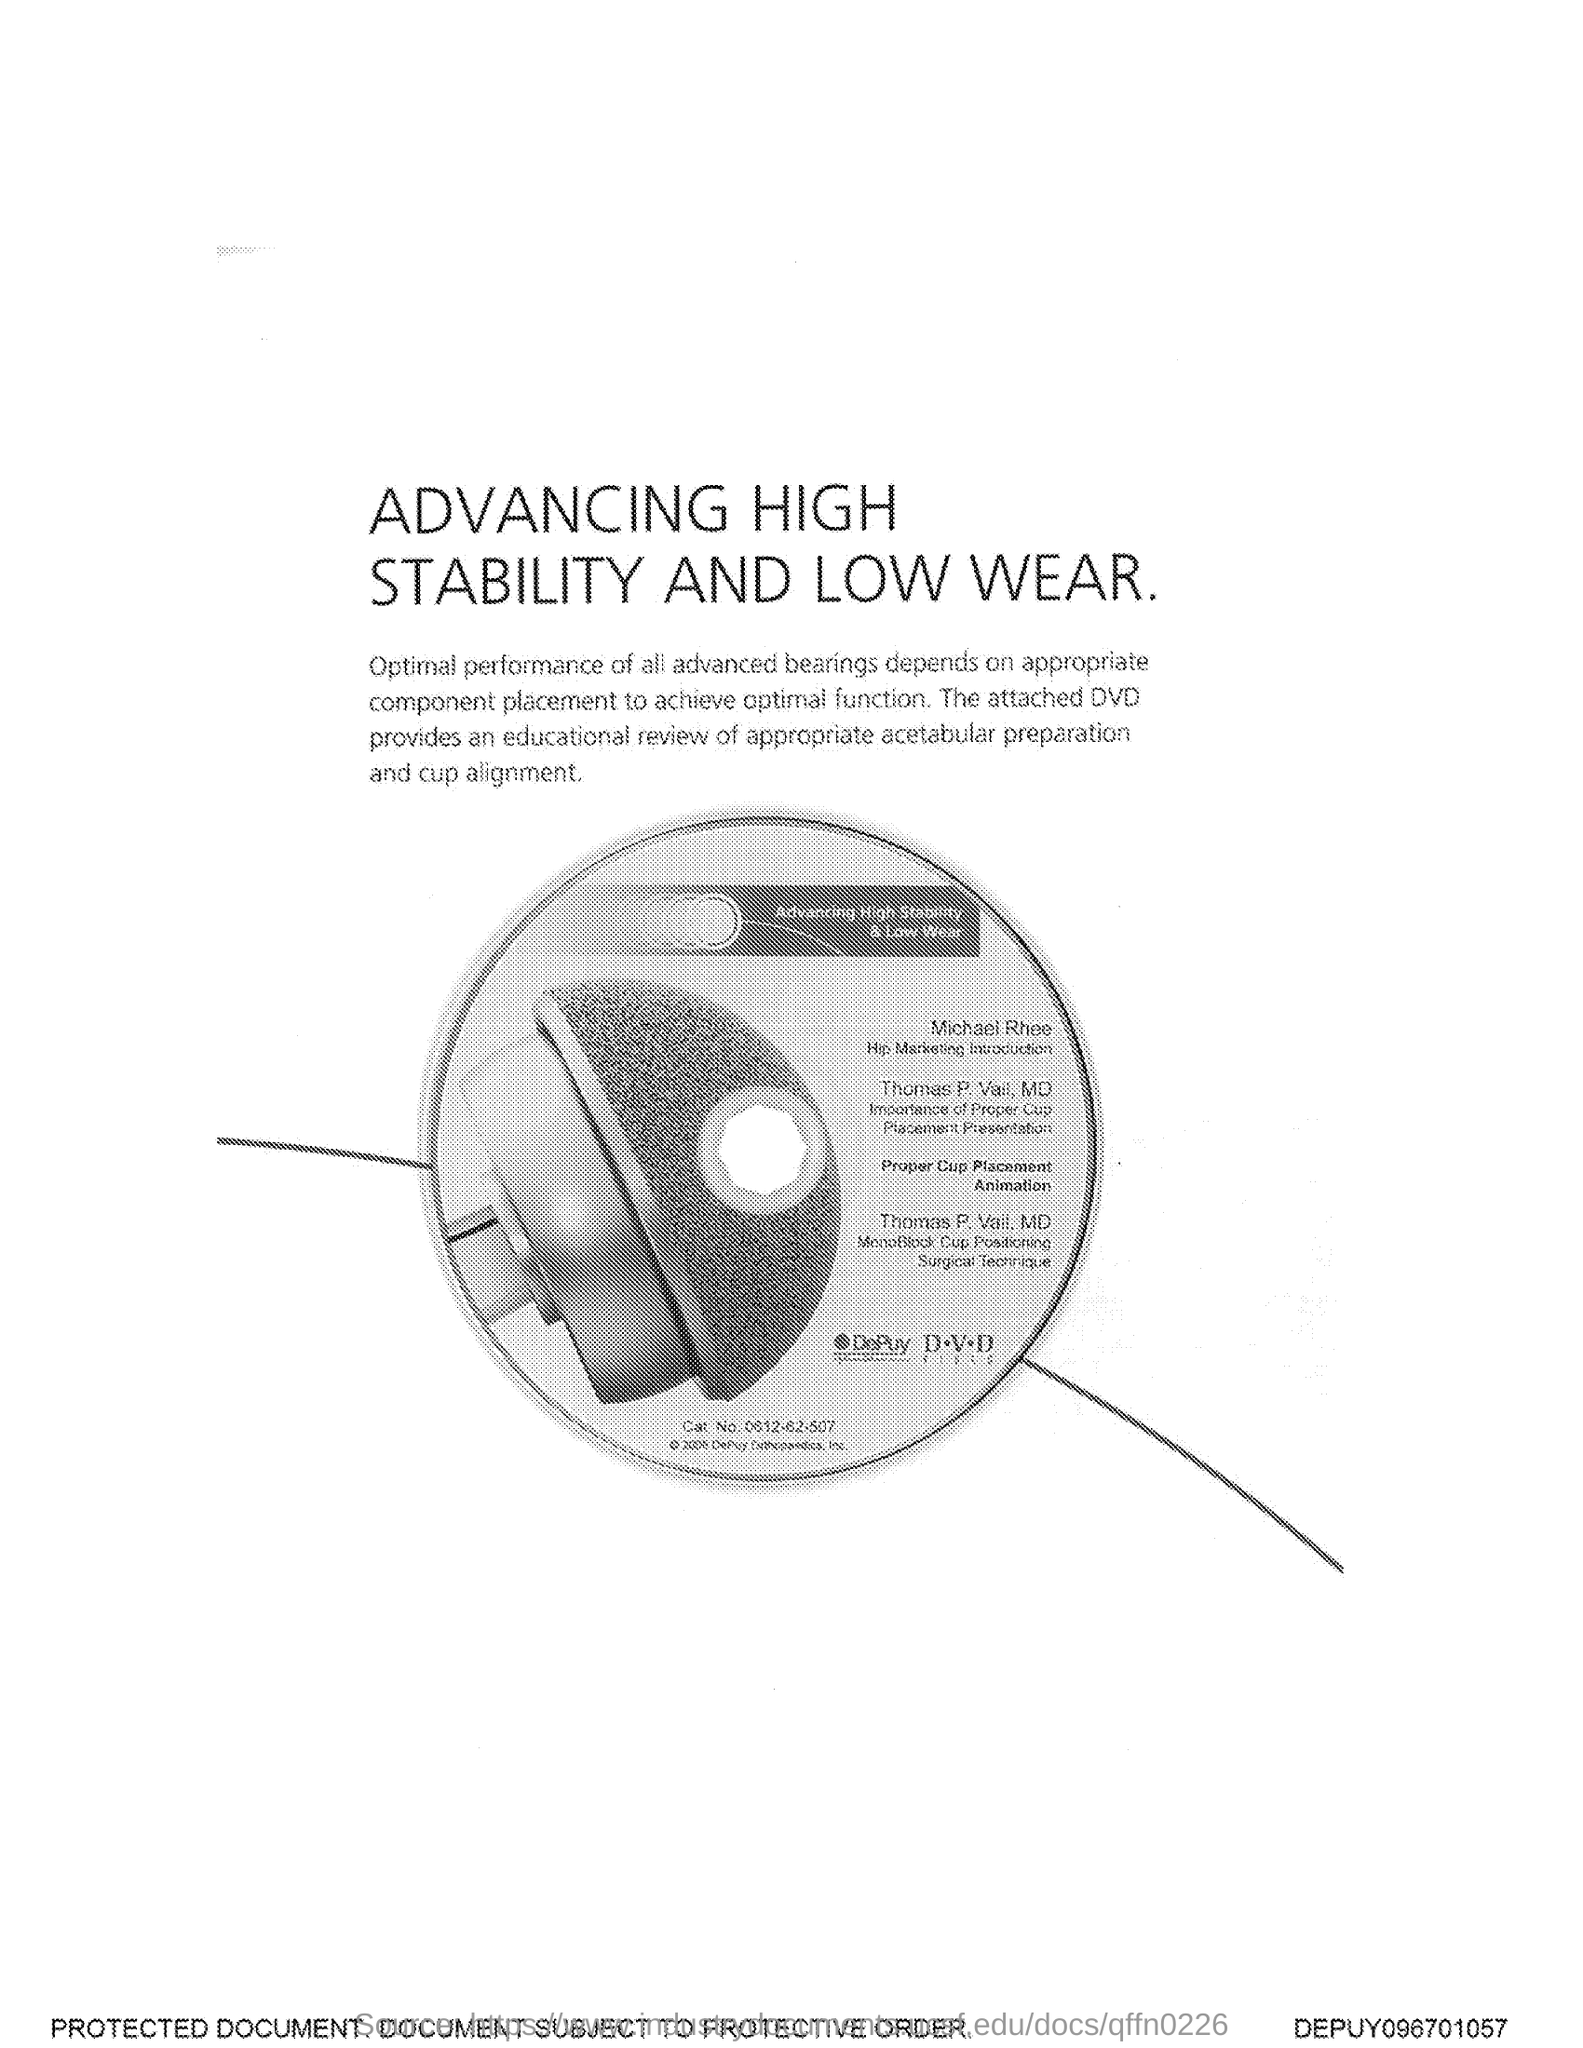What is the title of the document?
Provide a short and direct response. Advancing High Stability and Low Wear. 